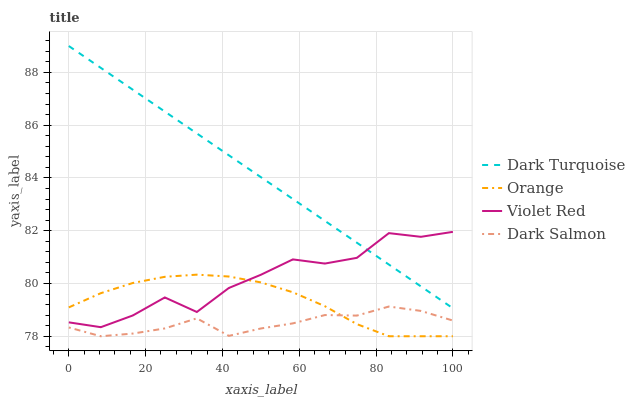Does Dark Salmon have the minimum area under the curve?
Answer yes or no. Yes. Does Dark Turquoise have the maximum area under the curve?
Answer yes or no. Yes. Does Violet Red have the minimum area under the curve?
Answer yes or no. No. Does Violet Red have the maximum area under the curve?
Answer yes or no. No. Is Dark Turquoise the smoothest?
Answer yes or no. Yes. Is Violet Red the roughest?
Answer yes or no. Yes. Is Violet Red the smoothest?
Answer yes or no. No. Is Dark Turquoise the roughest?
Answer yes or no. No. Does Orange have the lowest value?
Answer yes or no. Yes. Does Violet Red have the lowest value?
Answer yes or no. No. Does Dark Turquoise have the highest value?
Answer yes or no. Yes. Does Violet Red have the highest value?
Answer yes or no. No. Is Dark Salmon less than Dark Turquoise?
Answer yes or no. Yes. Is Dark Turquoise greater than Orange?
Answer yes or no. Yes. Does Orange intersect Violet Red?
Answer yes or no. Yes. Is Orange less than Violet Red?
Answer yes or no. No. Is Orange greater than Violet Red?
Answer yes or no. No. Does Dark Salmon intersect Dark Turquoise?
Answer yes or no. No. 